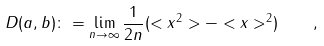Convert formula to latex. <formula><loc_0><loc_0><loc_500><loc_500>D ( a , b ) \colon = \lim _ { n \to \infty } \frac { 1 } { 2 n } ( < x ^ { 2 } > - < x > ^ { 2 } ) \quad ,</formula> 